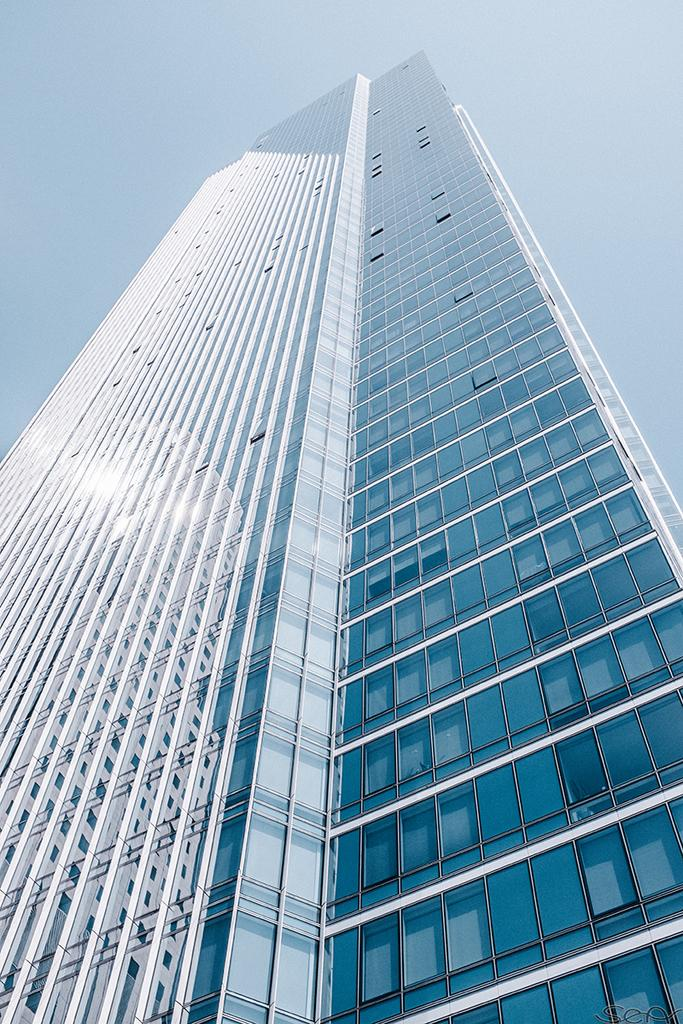What type of structure is present in the image? There is a building in the image. What can be seen in the background of the image? The sky is visible in the image. What theory is being discussed by the building in the image? There is no indication in the image that a theory is being discussed, as buildings do not engage in discussions. 